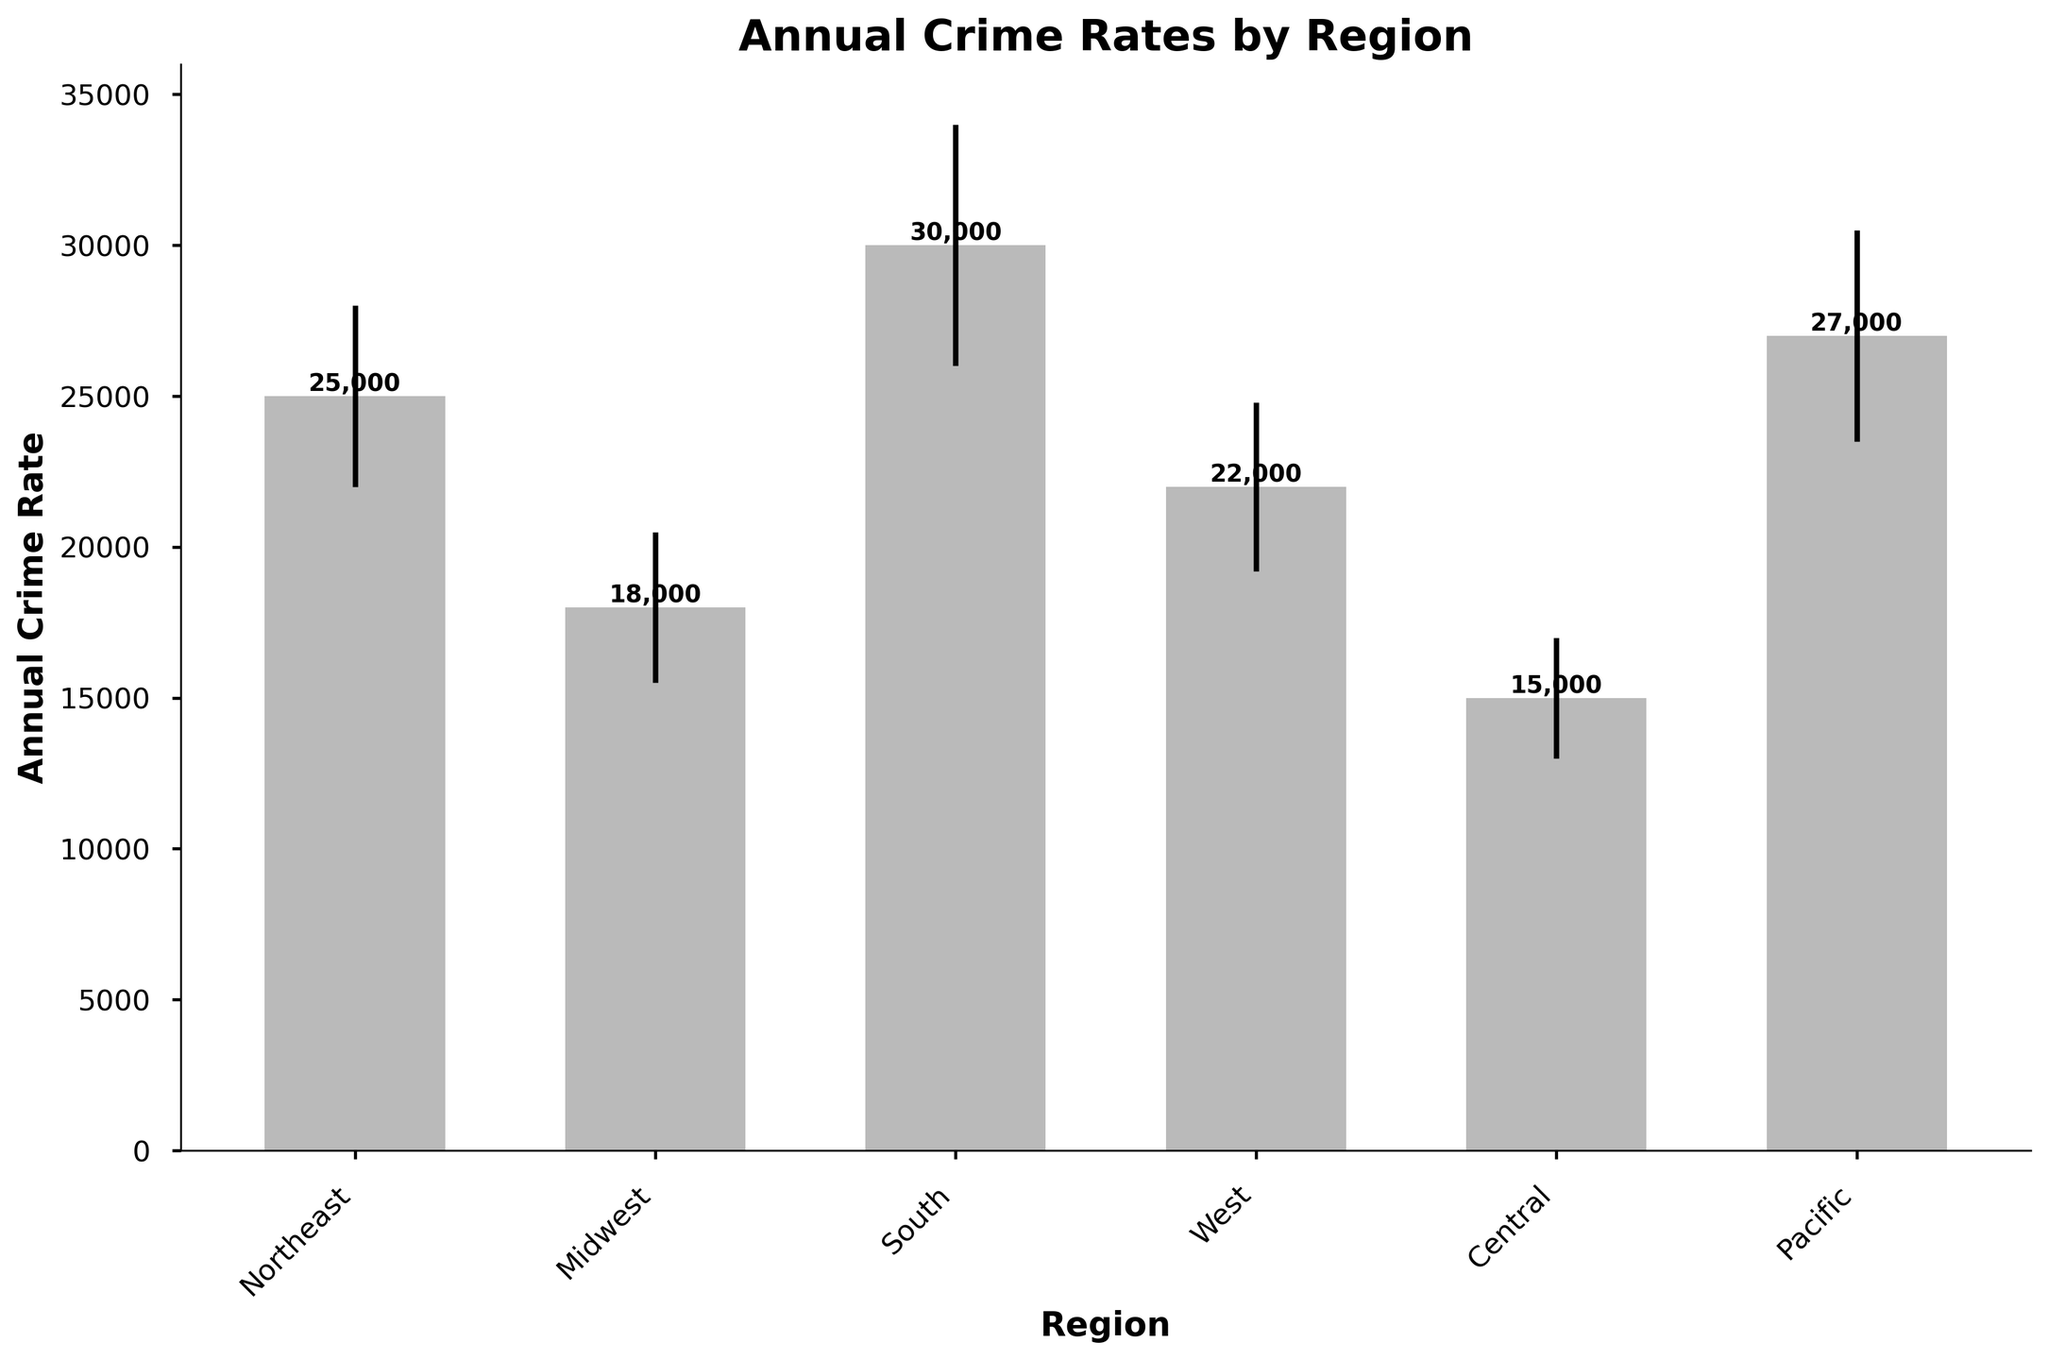what is the title of the figure? The title of the figure is displayed at the top and set in bold, making it the most visible text in the plot.
Answer: Annual Crime Rates by Region what are the regions displayed on the x-axis? The x-axis labels the different regions where the annual crime rates have been measured. The regions are listed from left to right. They are Northeast, Midwest, South, West, Central, and Pacific.
Answer: Northeast, Midwest, South, West, Central, Pacific which region has the highest annual crime rate? To find this, compare the heights of the bars. The bar with the greatest height corresponds to the South region.
Answer: South what is the annual crime rate for the Central region? Look at the height of the bar labeled "Central" on the x-axis and read the number on the y-axis corresponding to that height. The bar's height indicates an annual crime rate of 15,000.
Answer: 15,000 which region has the smallest standard deviation? To find this, compare the size of the error bars. The region with the smallest error bar is Central.
Answer: Central how much higher is the annual crime rate in the South compared to the Midwest? Find the heights of the bars for the South and Midwest regions. Subtract the Midwest's value (18,000) from the South's value (30,000). 30,000 - 18,000 = 12,000.
Answer: 12,000 what's the average annual crime rate across all regions? Add up the annual crime rates for all regions and divide by the number of regions. Total = 25,000 + 18,000 + 30,000 + 22,000 + 15,000 + 27,000 = 137,000. Average = 137,000 / 6 = 22,833.33
Answer: ~22,833 which region has the largest error bar? Compare the lengths of the error bars to find the largest one. The South has the longest error bar, indicating the highest standard deviation (4,000).
Answer: South 